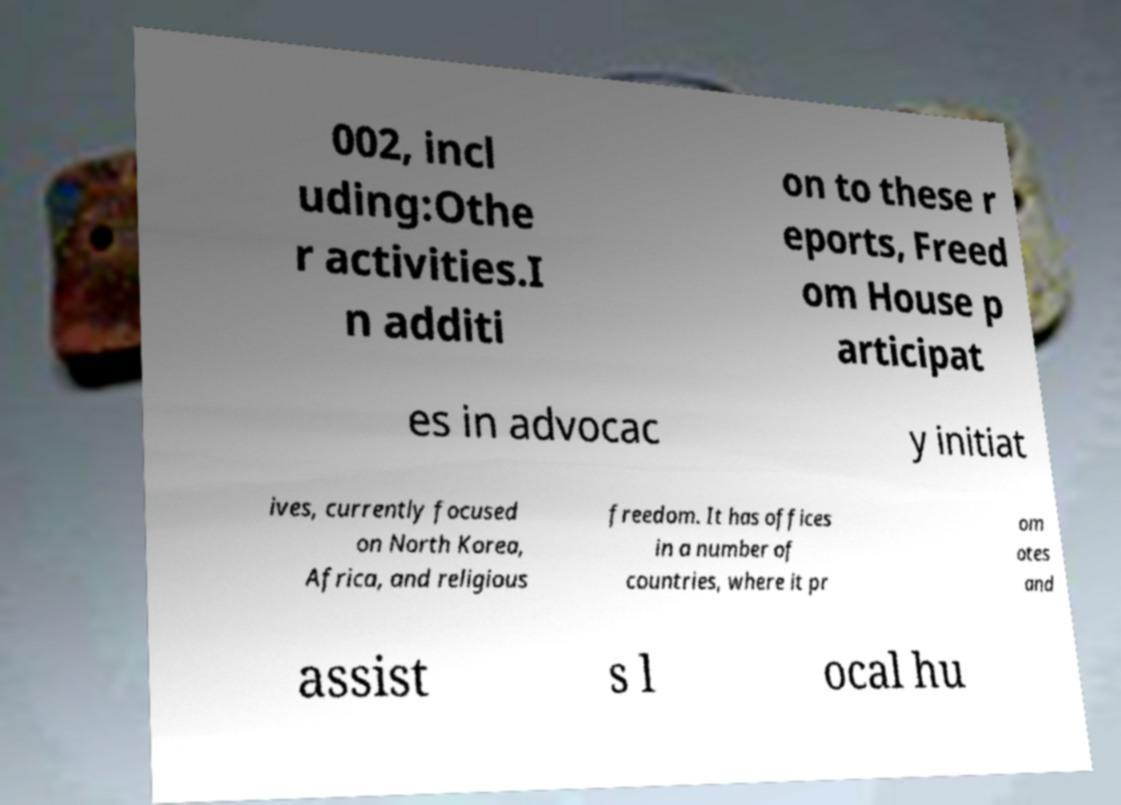For documentation purposes, I need the text within this image transcribed. Could you provide that? 002, incl uding:Othe r activities.I n additi on to these r eports, Freed om House p articipat es in advocac y initiat ives, currently focused on North Korea, Africa, and religious freedom. It has offices in a number of countries, where it pr om otes and assist s l ocal hu 